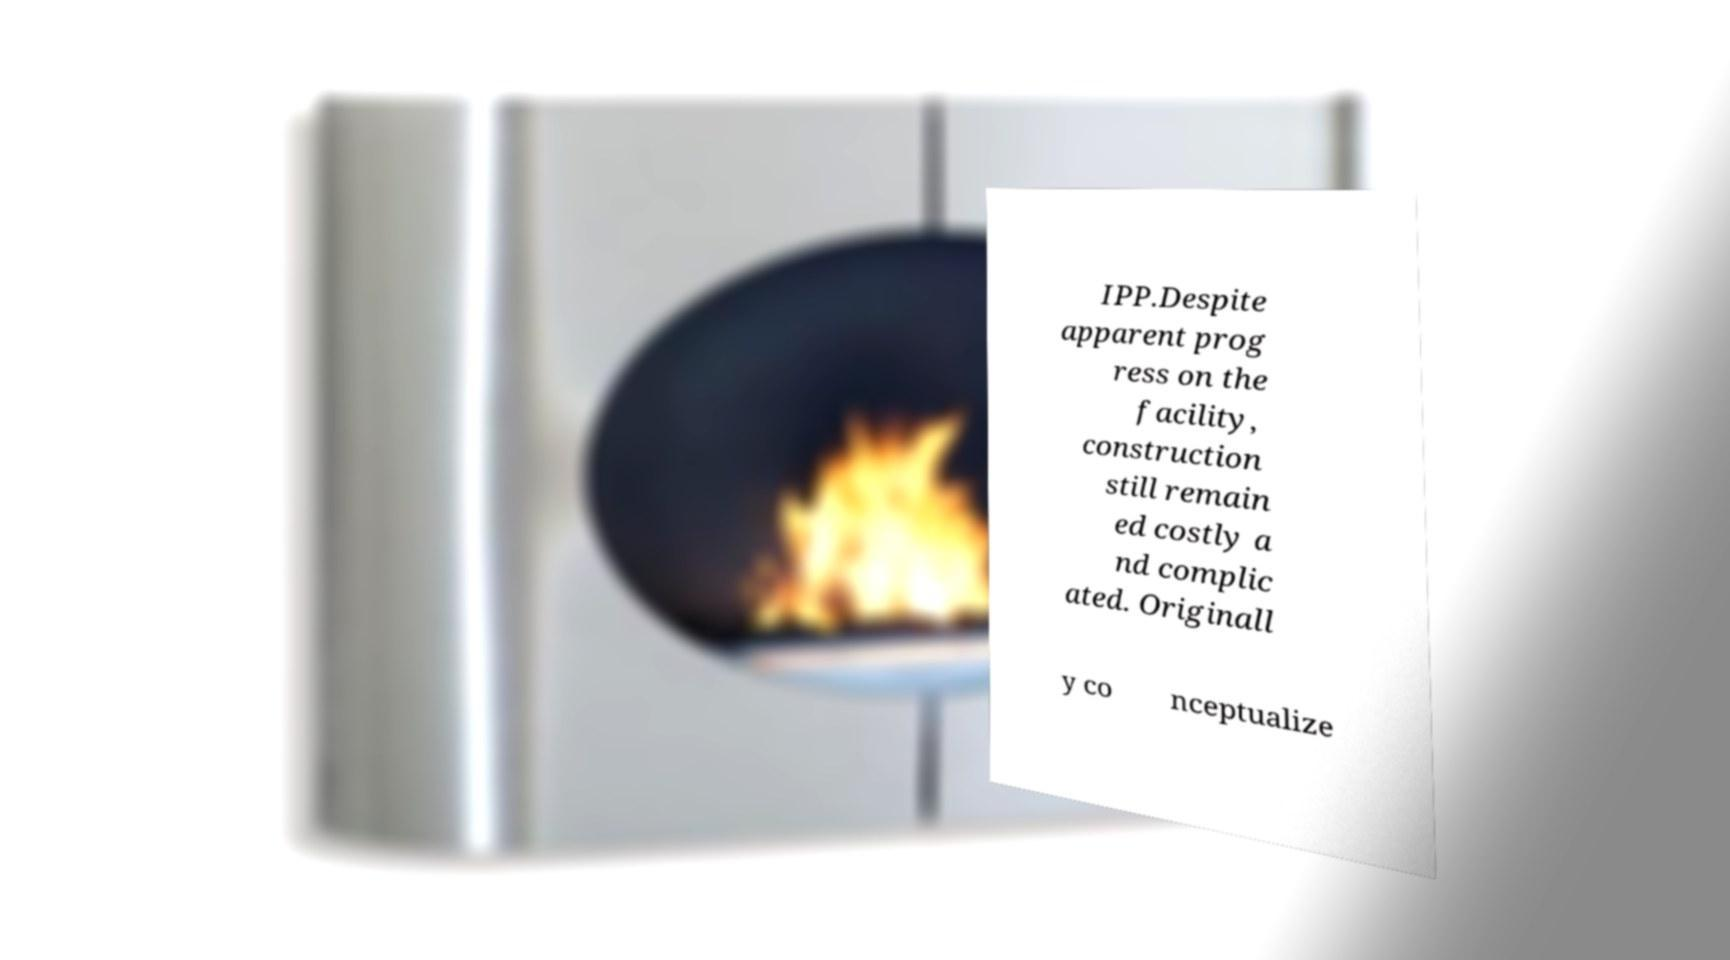I need the written content from this picture converted into text. Can you do that? IPP.Despite apparent prog ress on the facility, construction still remain ed costly a nd complic ated. Originall y co nceptualize 